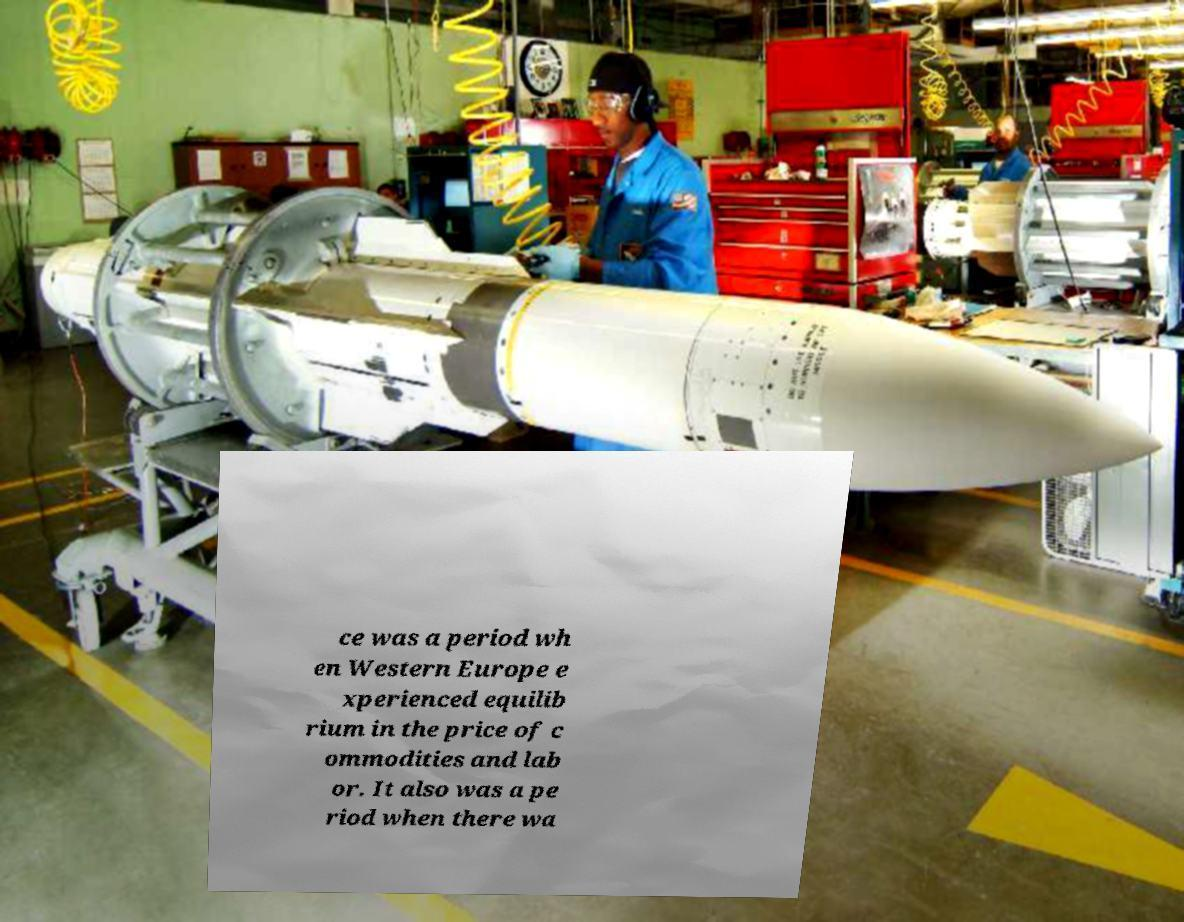For documentation purposes, I need the text within this image transcribed. Could you provide that? ce was a period wh en Western Europe e xperienced equilib rium in the price of c ommodities and lab or. It also was a pe riod when there wa 